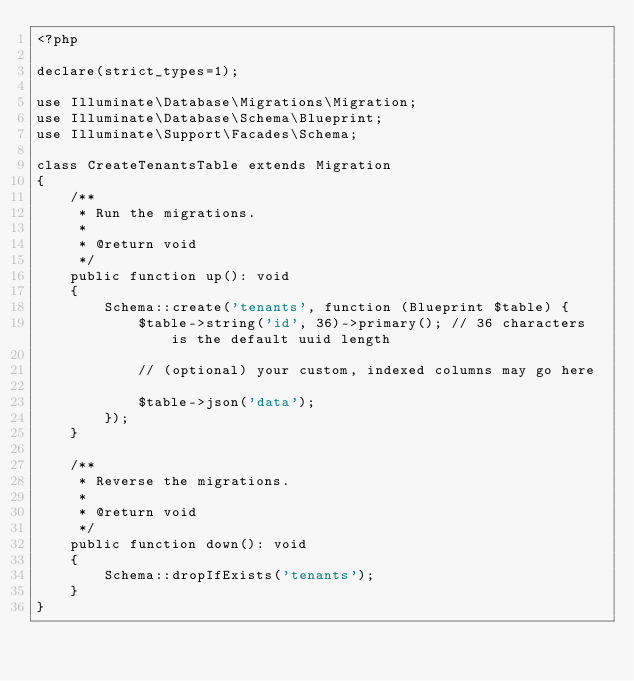Convert code to text. <code><loc_0><loc_0><loc_500><loc_500><_PHP_><?php

declare(strict_types=1);

use Illuminate\Database\Migrations\Migration;
use Illuminate\Database\Schema\Blueprint;
use Illuminate\Support\Facades\Schema;

class CreateTenantsTable extends Migration
{
    /**
     * Run the migrations.
     *
     * @return void
     */
    public function up(): void
    {
        Schema::create('tenants', function (Blueprint $table) {
            $table->string('id', 36)->primary(); // 36 characters is the default uuid length

            // (optional) your custom, indexed columns may go here

            $table->json('data');
        });
    }

    /**
     * Reverse the migrations.
     *
     * @return void
     */
    public function down(): void
    {
        Schema::dropIfExists('tenants');
    }
}
</code> 